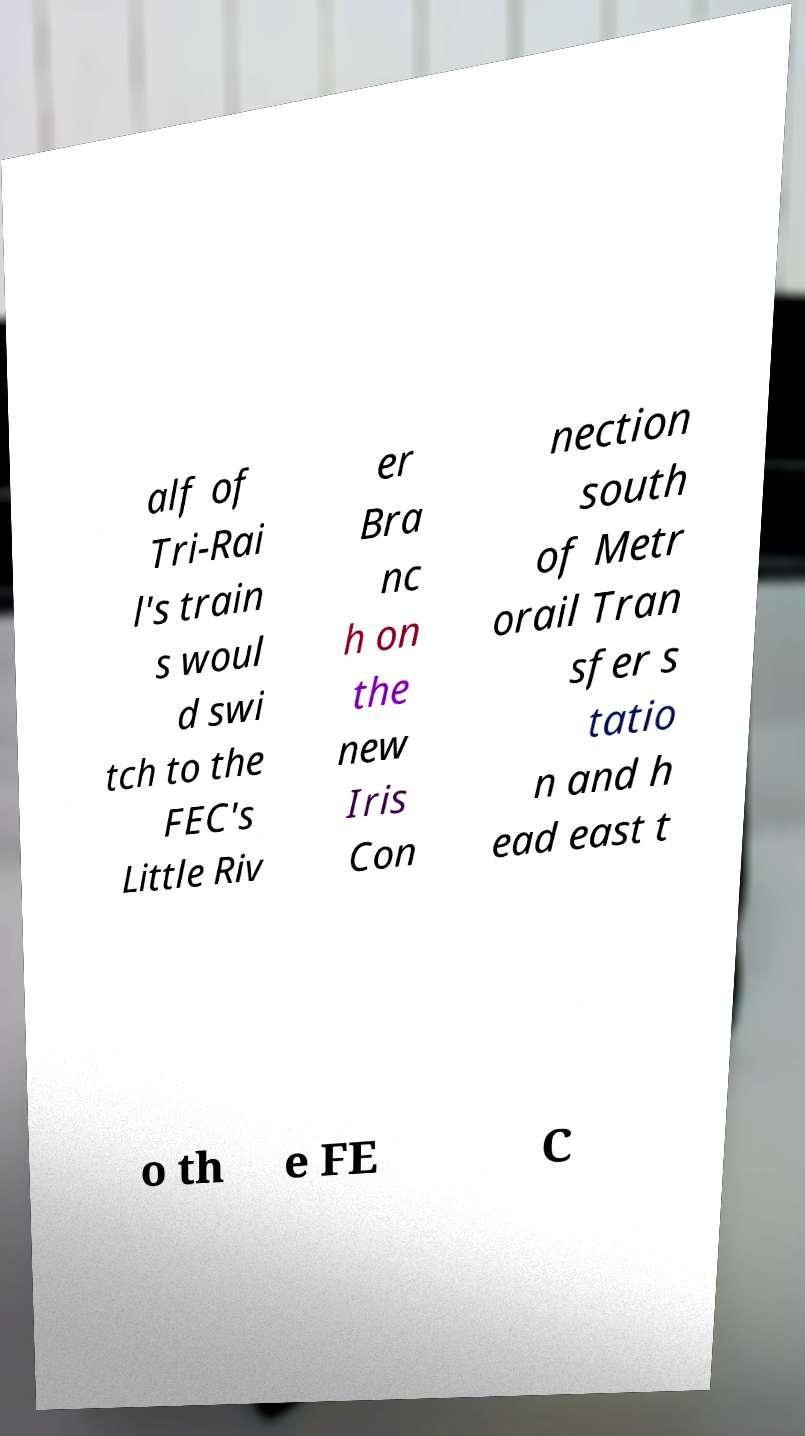What messages or text are displayed in this image? I need them in a readable, typed format. alf of Tri-Rai l's train s woul d swi tch to the FEC's Little Riv er Bra nc h on the new Iris Con nection south of Metr orail Tran sfer s tatio n and h ead east t o th e FE C 